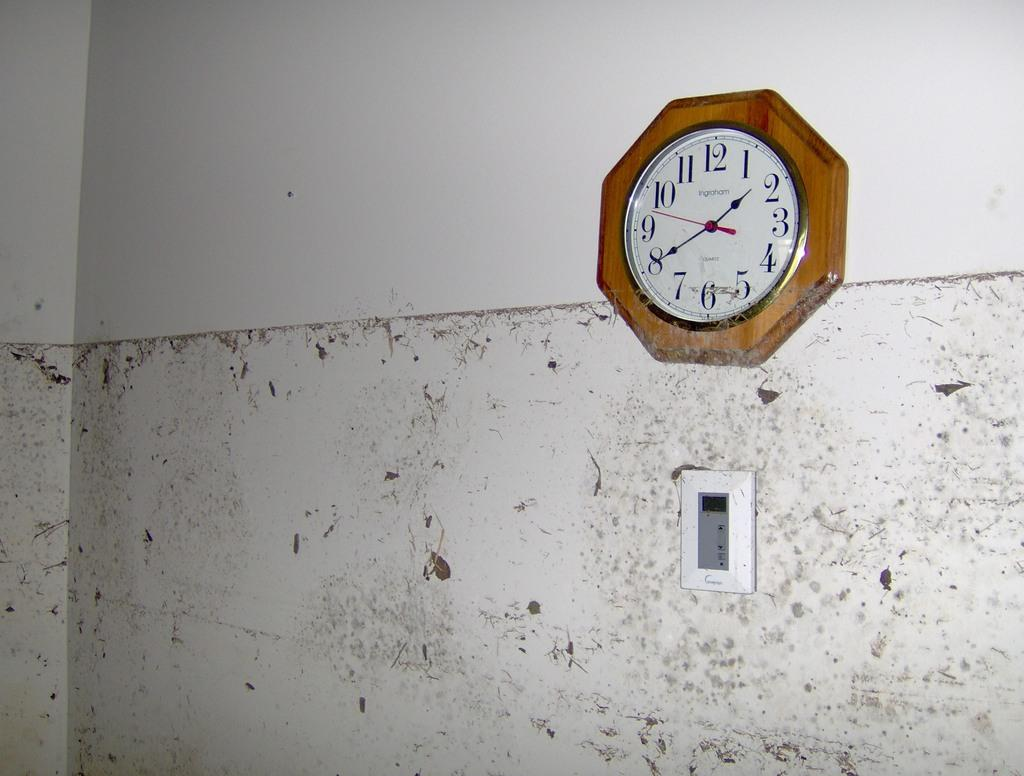<image>
Present a compact description of the photo's key features. A clock hangs on the wall and shows a time of 1:40. 